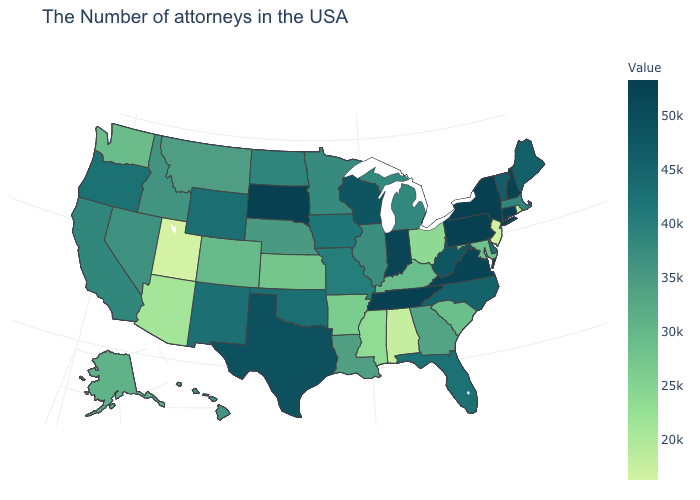Does Tennessee have the highest value in the South?
Quick response, please. Yes. Does Minnesota have the highest value in the USA?
Answer briefly. No. Which states have the lowest value in the Northeast?
Be succinct. New Jersey. Among the states that border Colorado , which have the lowest value?
Short answer required. Utah. Does Utah have the lowest value in the USA?
Keep it brief. Yes. 